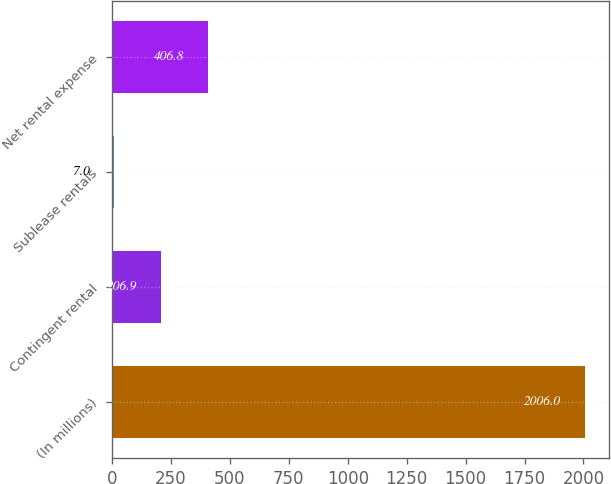Convert chart to OTSL. <chart><loc_0><loc_0><loc_500><loc_500><bar_chart><fcel>(In millions)<fcel>Contingent rental<fcel>Sublease rentals<fcel>Net rental expense<nl><fcel>2006<fcel>206.9<fcel>7<fcel>406.8<nl></chart> 